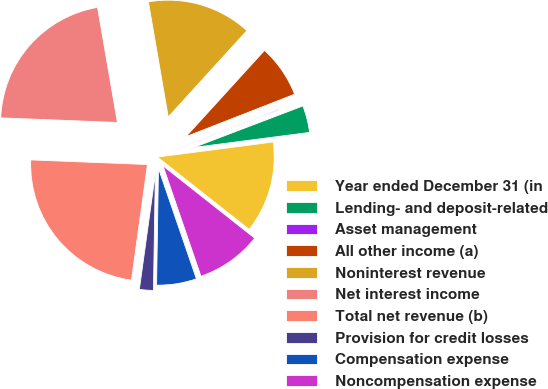<chart> <loc_0><loc_0><loc_500><loc_500><pie_chart><fcel>Year ended December 31 (in<fcel>Lending- and deposit-related<fcel>Asset management<fcel>All other income (a)<fcel>Noninterest revenue<fcel>Net interest income<fcel>Total net revenue (b)<fcel>Provision for credit losses<fcel>Compensation expense<fcel>Noncompensation expense<nl><fcel>12.69%<fcel>3.73%<fcel>0.14%<fcel>7.31%<fcel>14.48%<fcel>21.65%<fcel>23.44%<fcel>1.93%<fcel>5.52%<fcel>9.1%<nl></chart> 